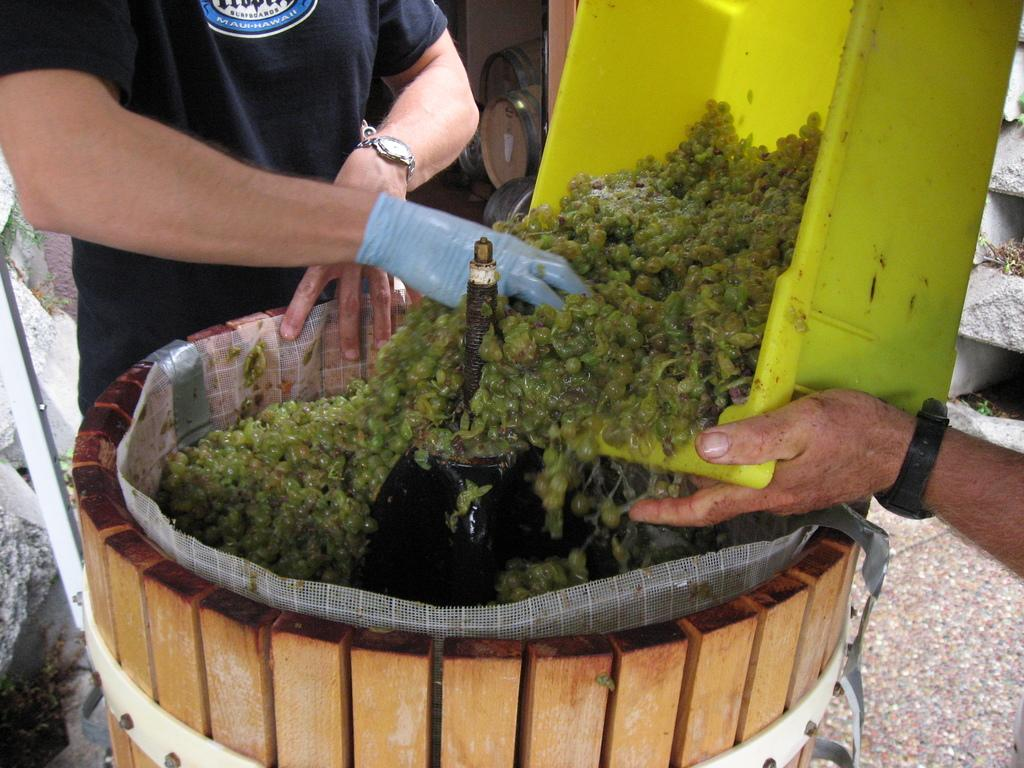What are the people in the image doing? People are preparing food in the image. Can you describe the attire of one of the individuals? There is a man wearing gloves in the image. What type of insurance policy is being discussed by the people in the image? There is no mention of insurance or any discussion in the image; people are simply preparing food. 